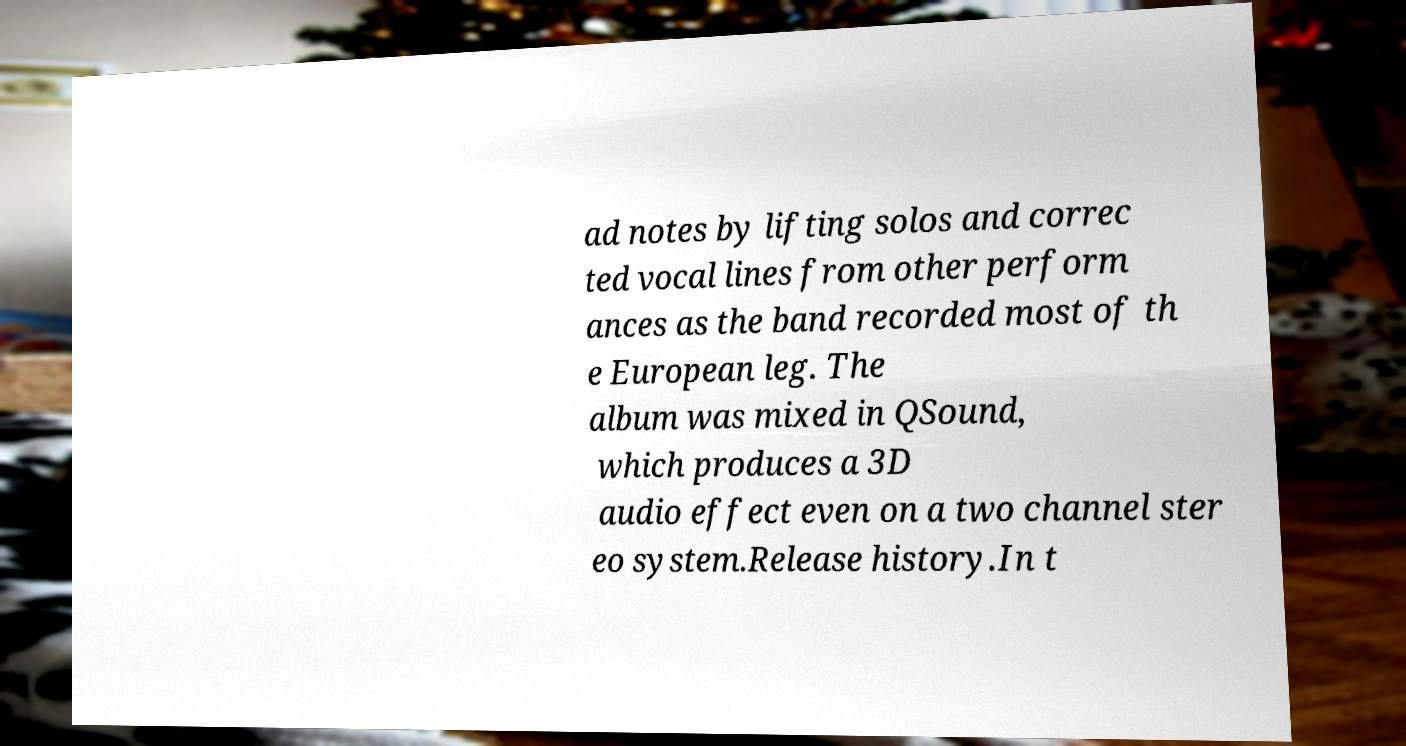Please identify and transcribe the text found in this image. ad notes by lifting solos and correc ted vocal lines from other perform ances as the band recorded most of th e European leg. The album was mixed in QSound, which produces a 3D audio effect even on a two channel ster eo system.Release history.In t 